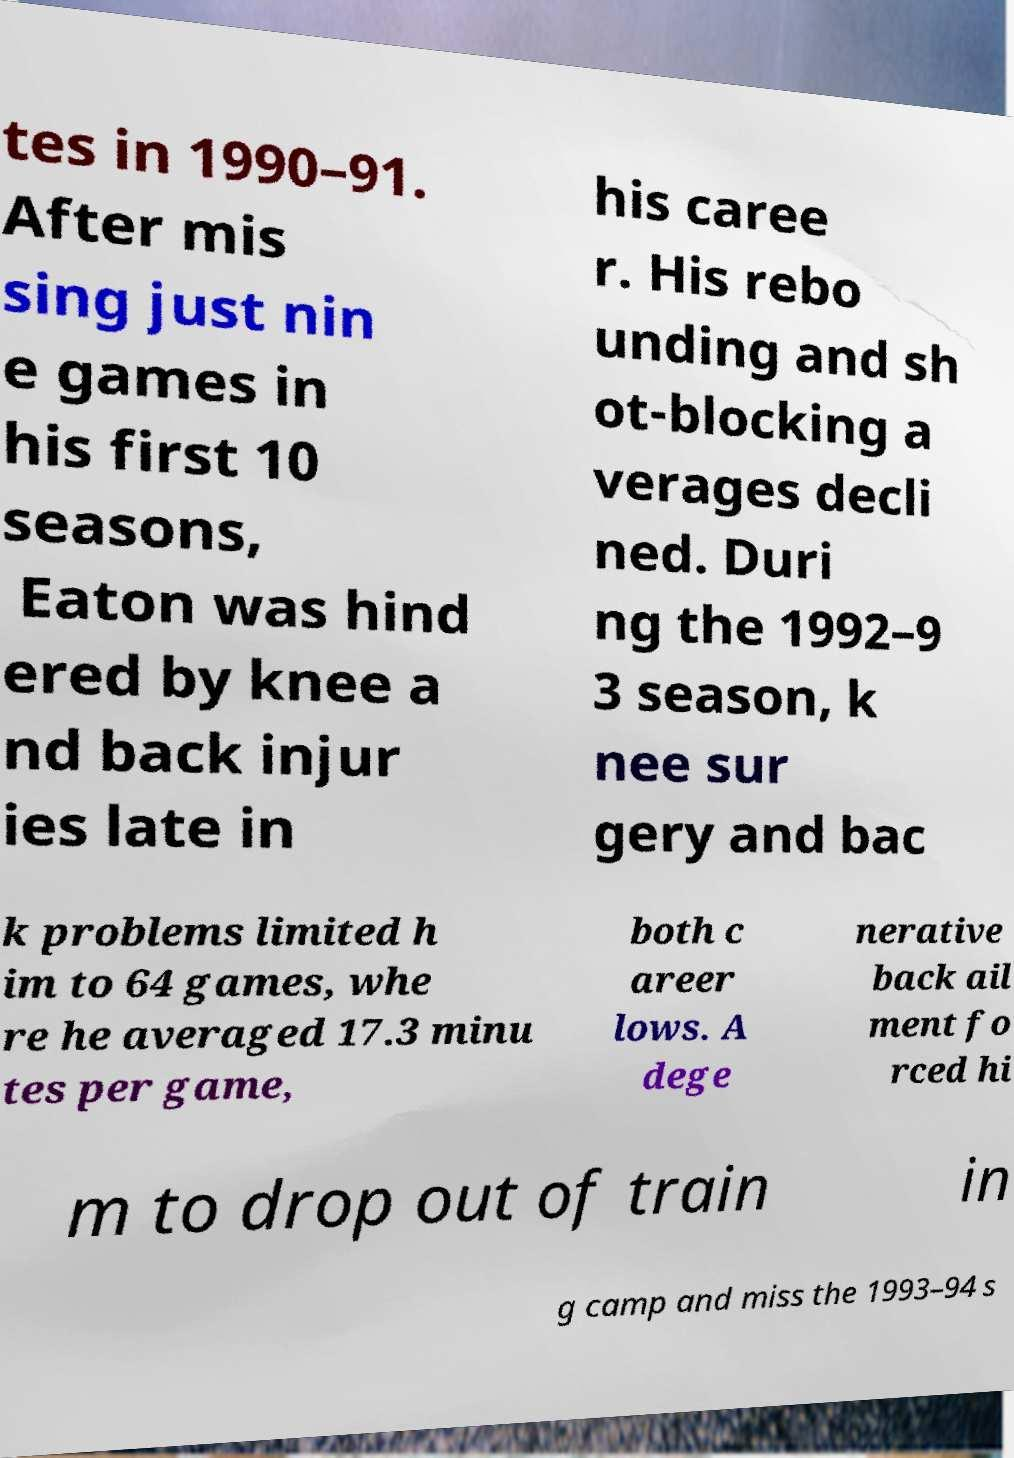What messages or text are displayed in this image? I need them in a readable, typed format. tes in 1990–91. After mis sing just nin e games in his first 10 seasons, Eaton was hind ered by knee a nd back injur ies late in his caree r. His rebo unding and sh ot-blocking a verages decli ned. Duri ng the 1992–9 3 season, k nee sur gery and bac k problems limited h im to 64 games, whe re he averaged 17.3 minu tes per game, both c areer lows. A dege nerative back ail ment fo rced hi m to drop out of train in g camp and miss the 1993–94 s 